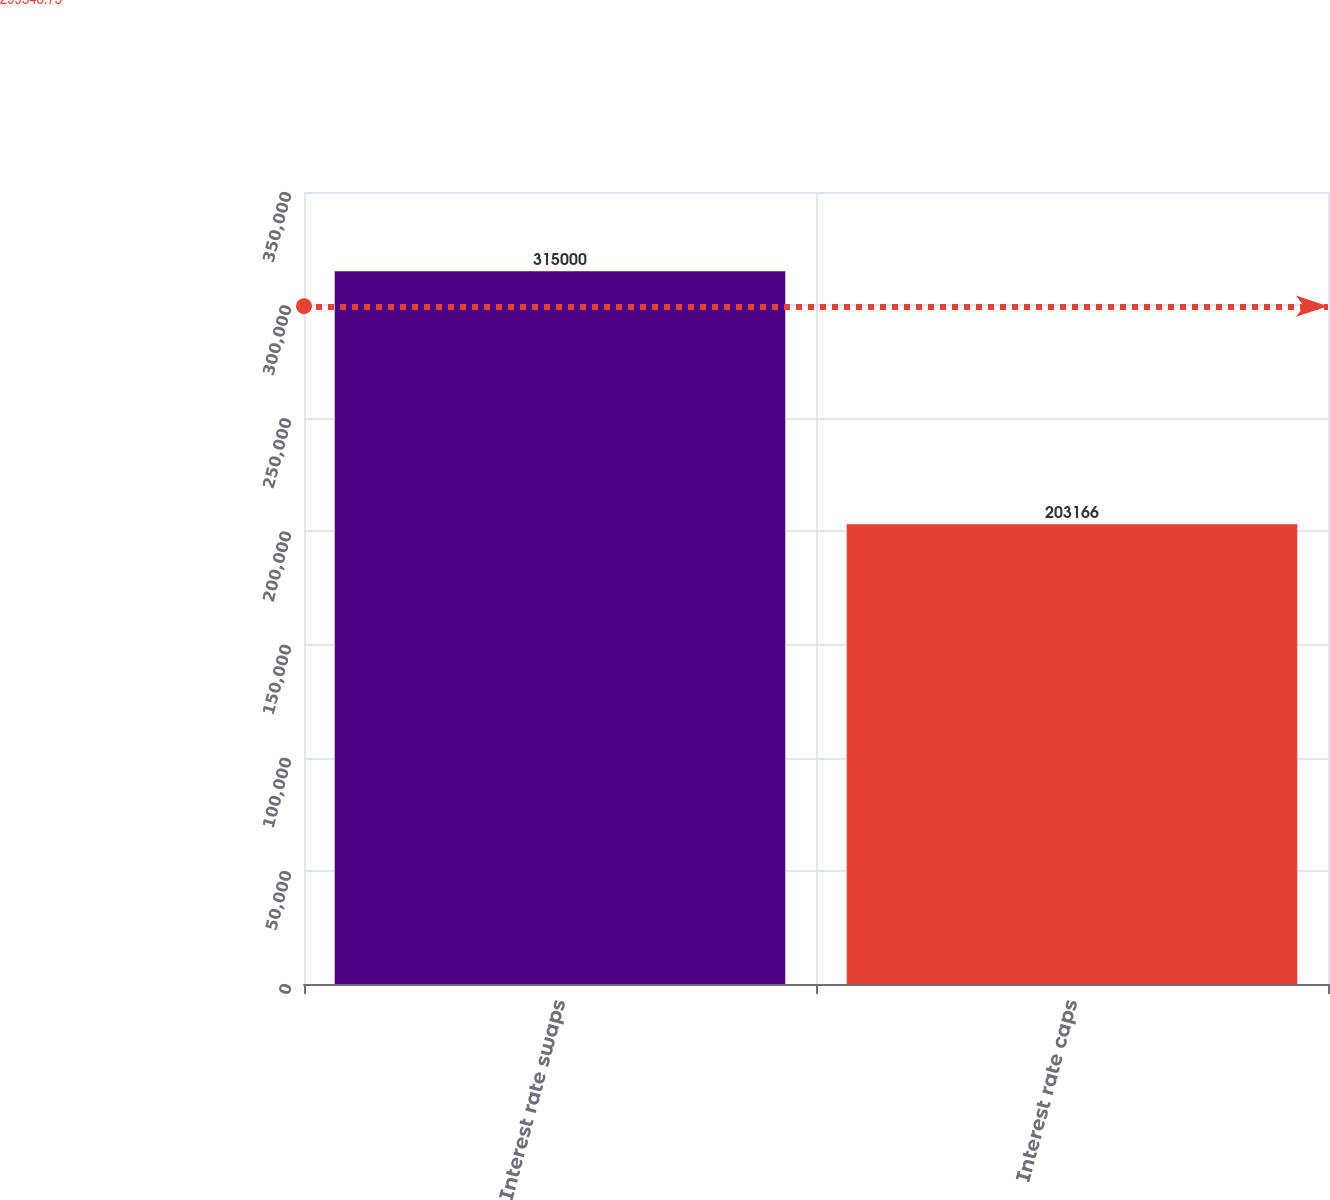<chart> <loc_0><loc_0><loc_500><loc_500><bar_chart><fcel>Interest rate swaps<fcel>Interest rate caps<nl><fcel>315000<fcel>203166<nl></chart> 